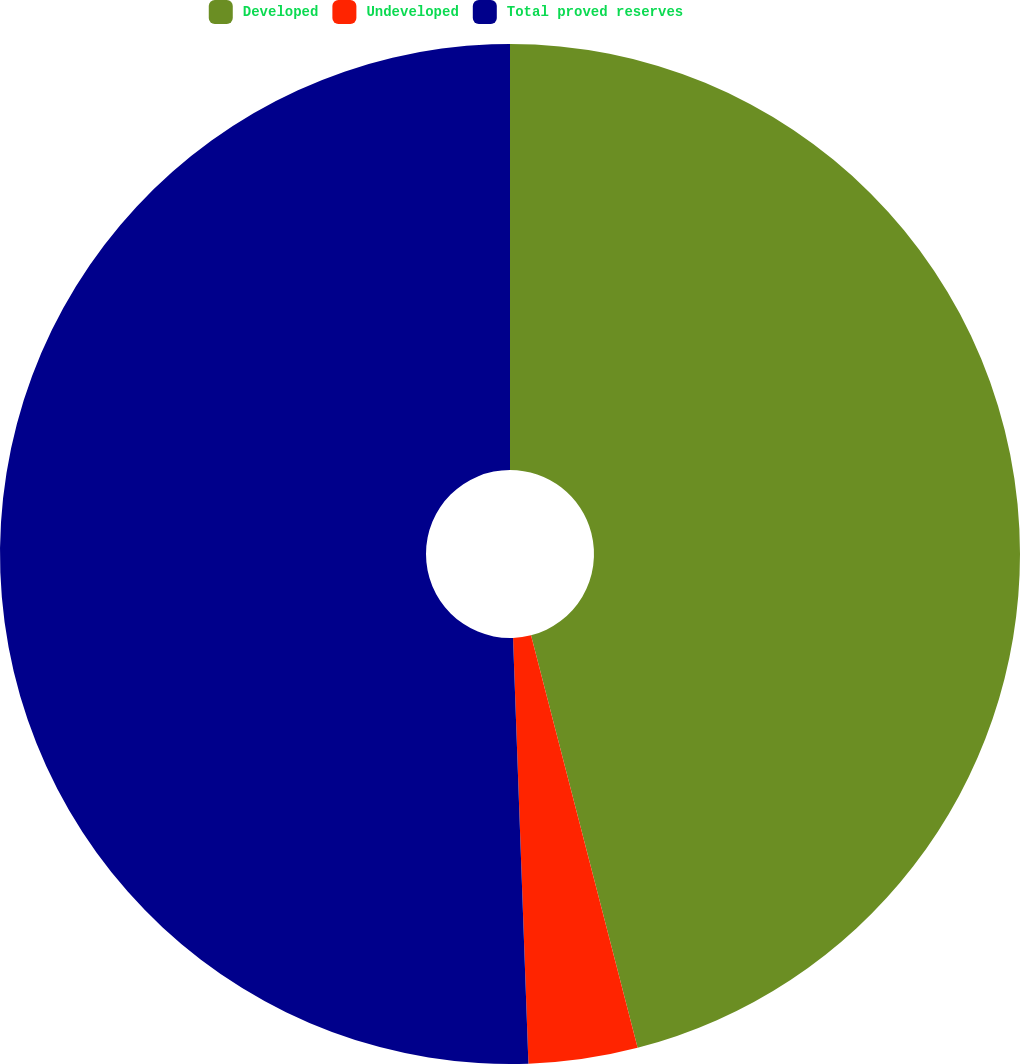Convert chart to OTSL. <chart><loc_0><loc_0><loc_500><loc_500><pie_chart><fcel>Developed<fcel>Undeveloped<fcel>Total proved reserves<nl><fcel>45.97%<fcel>3.45%<fcel>50.57%<nl></chart> 